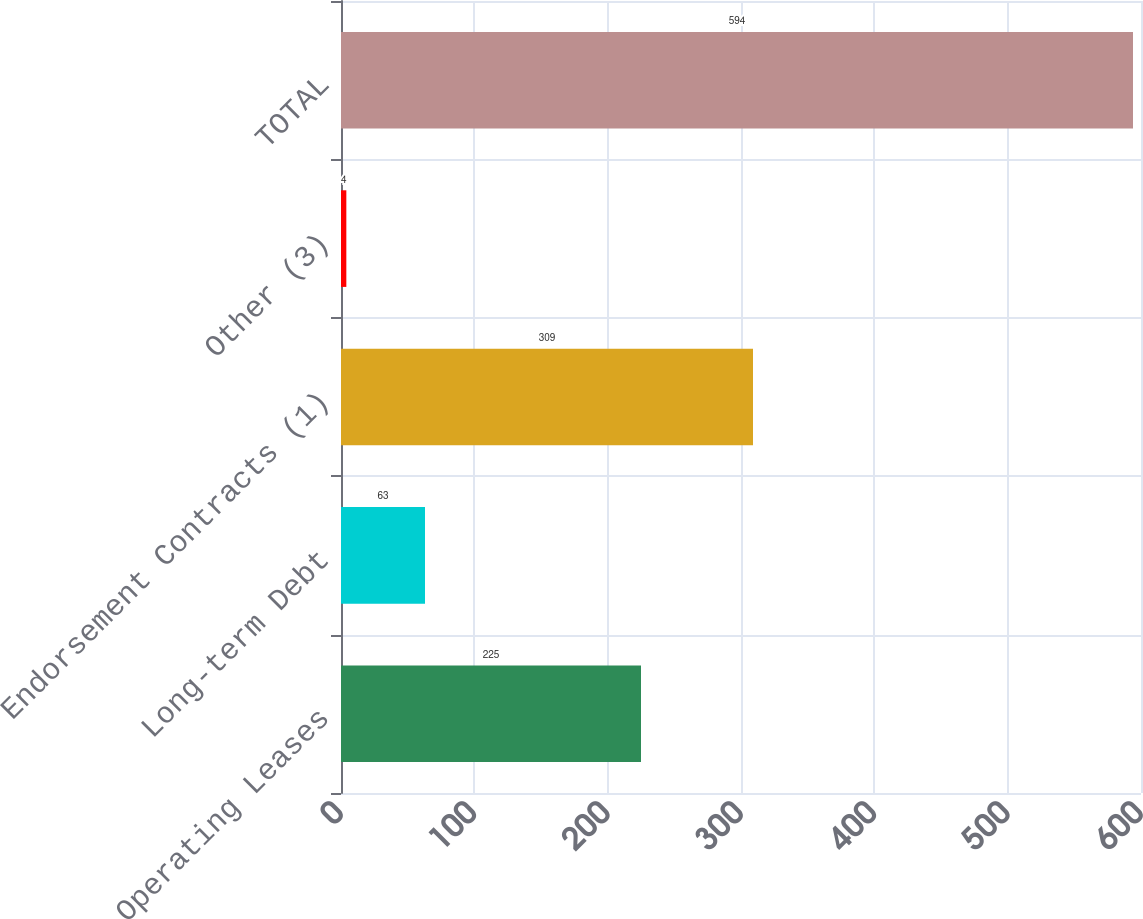Convert chart to OTSL. <chart><loc_0><loc_0><loc_500><loc_500><bar_chart><fcel>Operating Leases<fcel>Long-term Debt<fcel>Endorsement Contracts (1)<fcel>Other (3)<fcel>TOTAL<nl><fcel>225<fcel>63<fcel>309<fcel>4<fcel>594<nl></chart> 